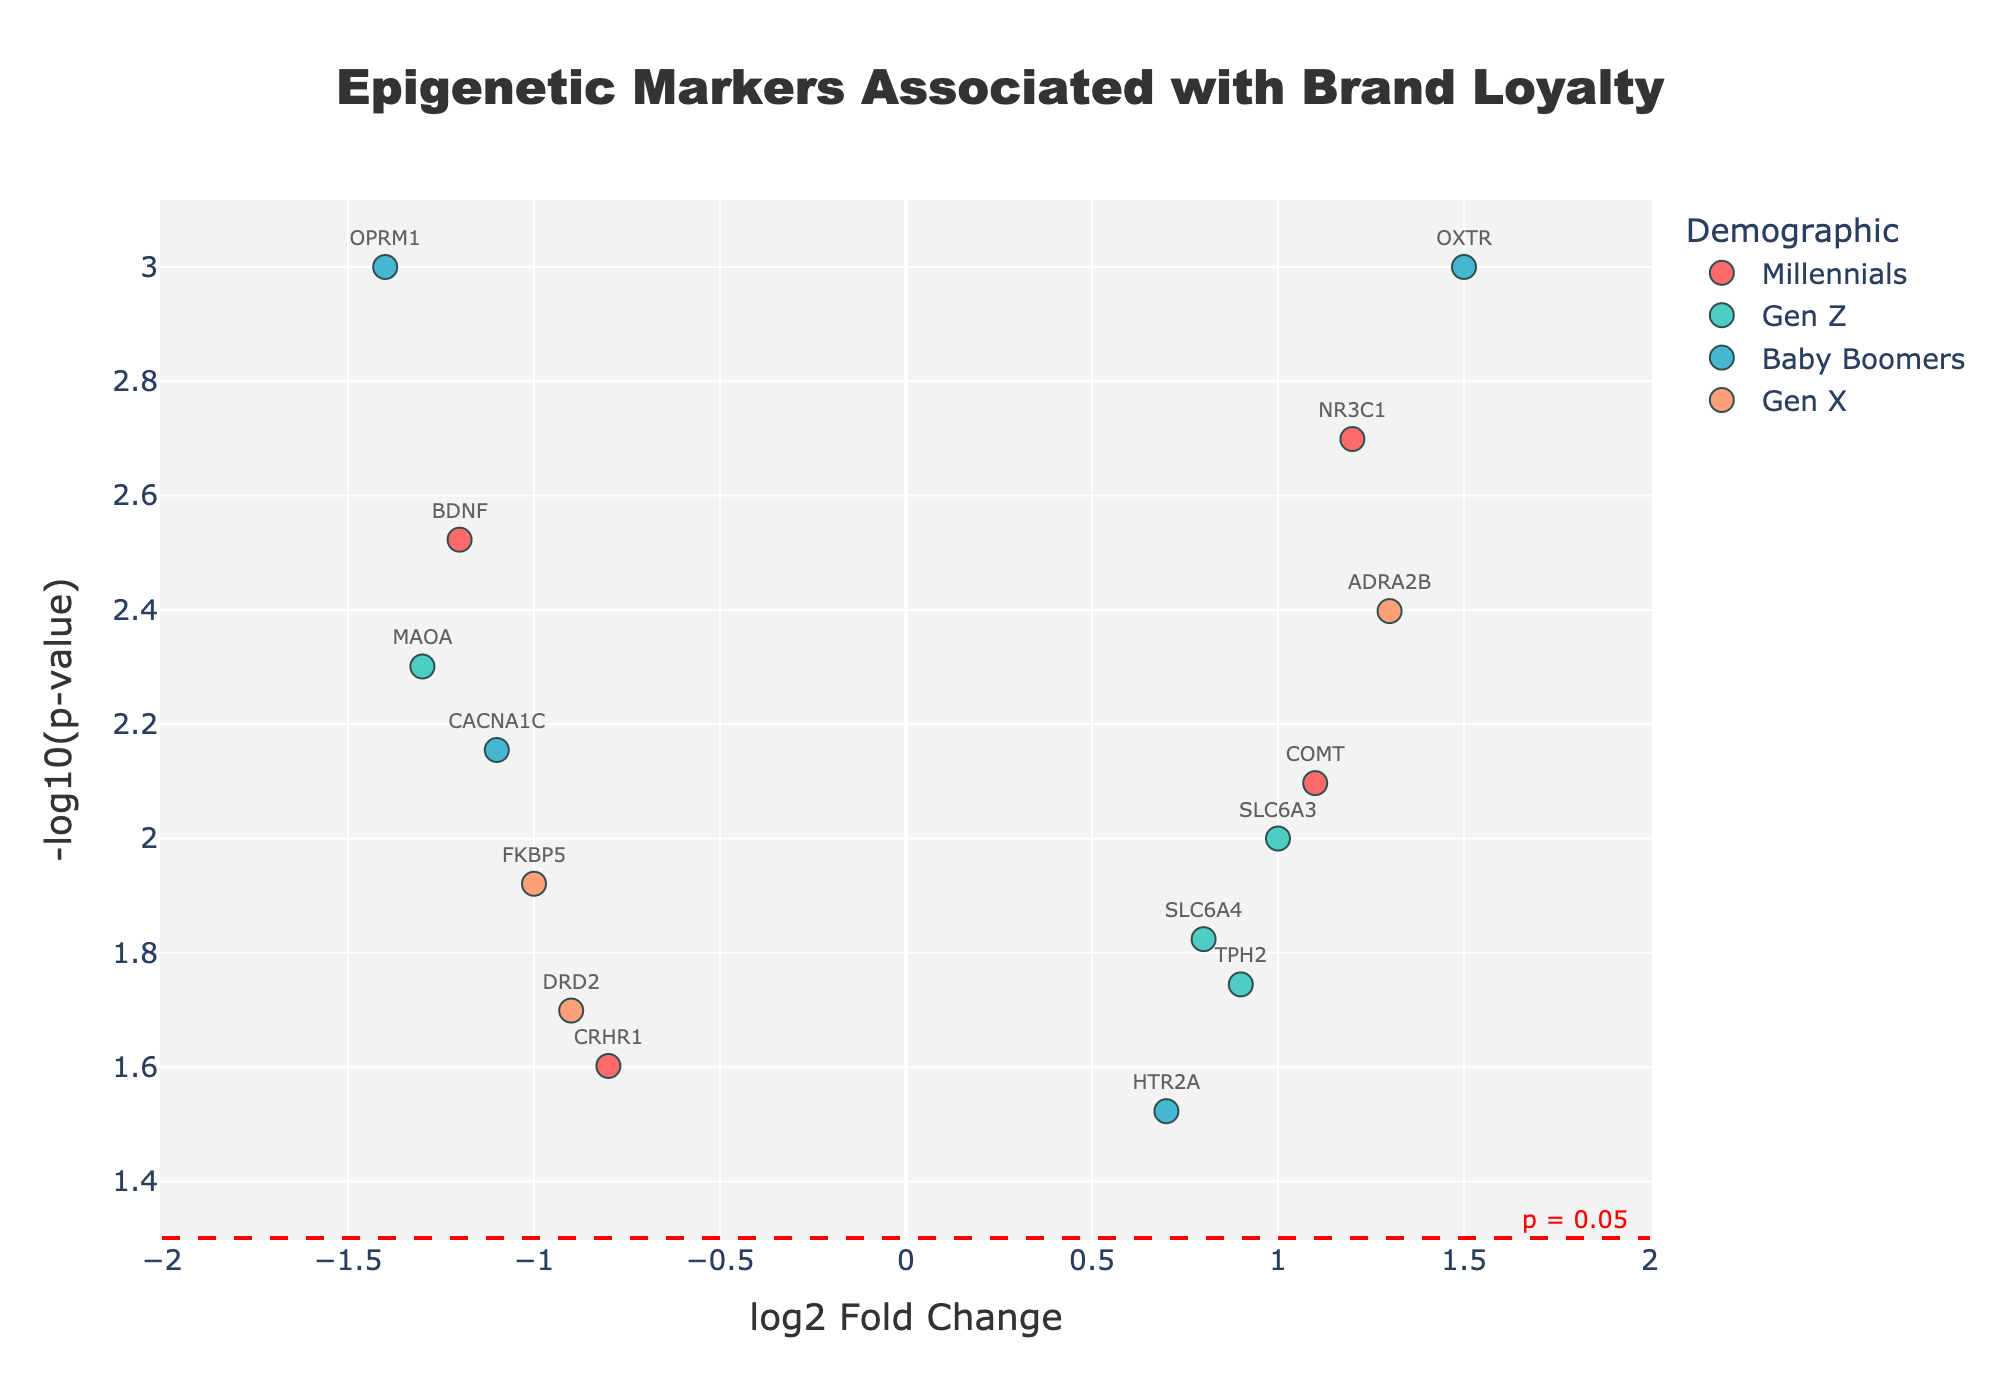What is the title of the plot? The title is located at the top center of the plot. It describes what the plot is about.
Answer: Epigenetic Markers Associated with Brand Loyalty How many data points represent Baby Boomers? Count the number of points associated with the demographic "Baby Boomers," which can be identified by their unique color or legend label.
Answer: 4 Which gene shows the highest -log10(p-value)? Identify the point with the highest y-axis value (representing -log10(p-value)) and look at the associated text label to determine the gene.
Answer: OPRM1 What is the log2 fold change of the gene NR3C1? Locate the NR3C1 label in the plot and check its position on the x-axis to find the log2 fold change value.
Answer: 1.2 Which demographic group has the most markers with a negative log2 fold change? Count the data points with negative x-axis values for each demographic group based on their color or legend label and determine the group with the highest count.
Answer: Millennials How does the log2 fold change of DRD2 compare to that of CACNA1C? Identify the positions of DRD2 and CACNA1C on the x-axis and compare their values. DRD2 has a log2 fold change of -0.9, and CACNA1C has -1.1; therefore, DRD2 has a higher fold change.
Answer: DRD2 has a higher log2 fold change than CACNA1C Is the gene SLC6A3 significant at p < 0.05? Check whether the SLC6A3 point is above the significance threshold line (represented by p = 0.05) on the plot.
Answer: Yes What is the color associated with Gen X? Use the legend to identify the color representing Gen X.
Answer: Light orange For Millennials, which gene has the highest -log10(p-value)? Among the points color-coded for Millennials, find the one with the highest position on the y-axis and check its label.
Answer: NR3C1 Which two genes have the closest log2 fold change values? Compare the positions of the points on the x-axis to see which two are closest together.
Answer: DRD2 and FKBP5 